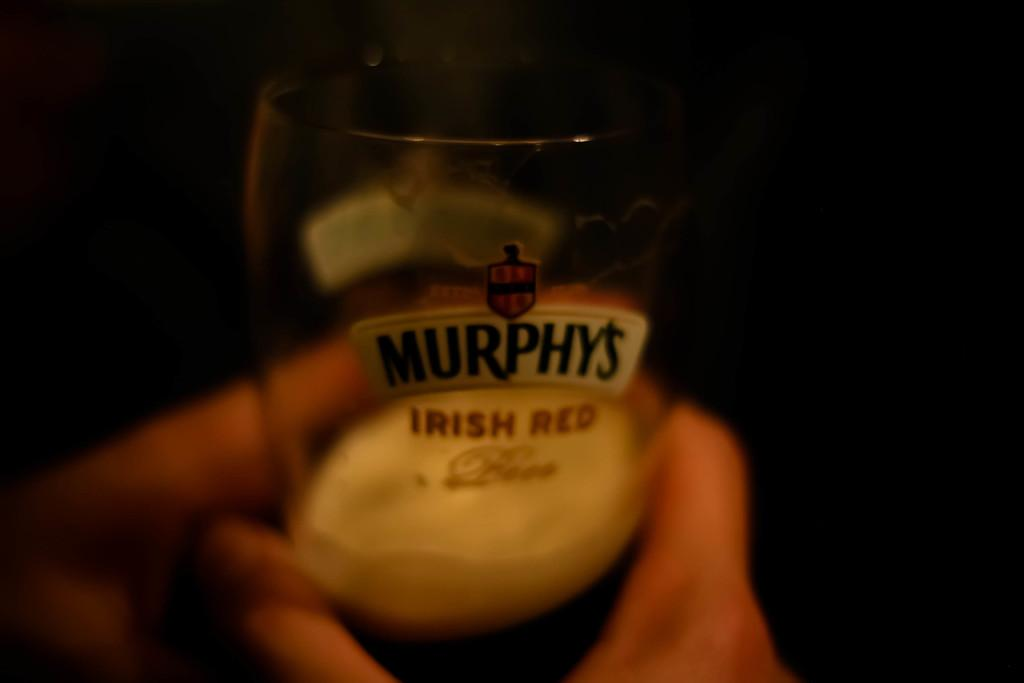<image>
Present a compact description of the photo's key features. A small glass of Murphy's Irish Red is being held in a hand. 